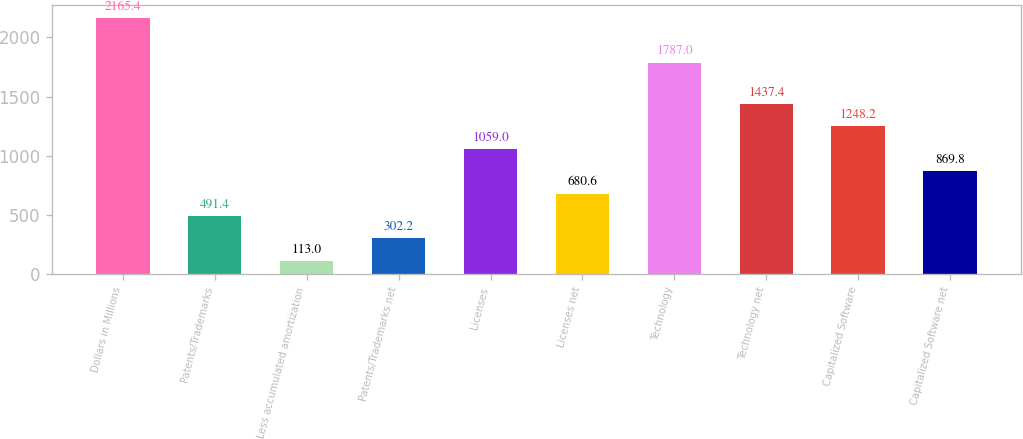Convert chart. <chart><loc_0><loc_0><loc_500><loc_500><bar_chart><fcel>Dollars in Millions<fcel>Patents/Trademarks<fcel>Less accumulated amortization<fcel>Patents/Trademarks net<fcel>Licenses<fcel>Licenses net<fcel>Technology<fcel>Technology net<fcel>Capitalized Software<fcel>Capitalized Software net<nl><fcel>2165.4<fcel>491.4<fcel>113<fcel>302.2<fcel>1059<fcel>680.6<fcel>1787<fcel>1437.4<fcel>1248.2<fcel>869.8<nl></chart> 